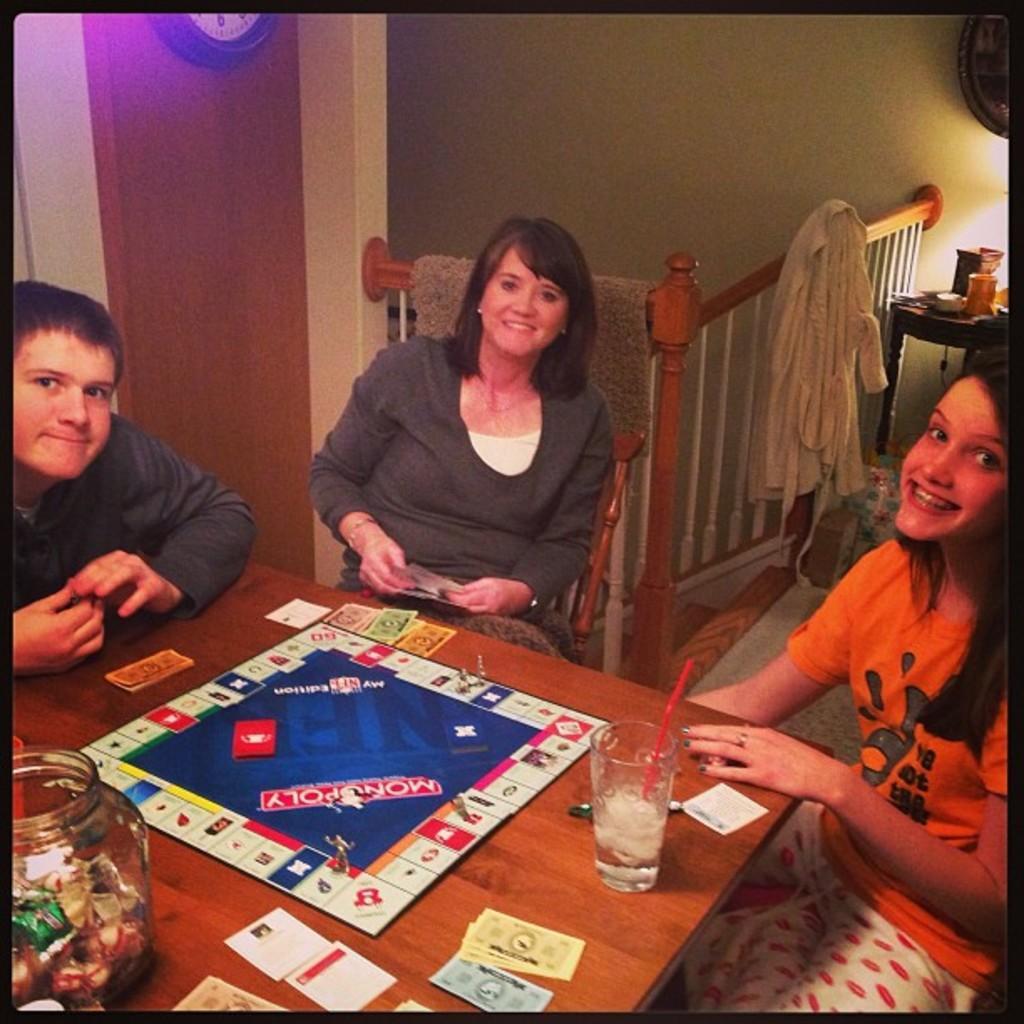Describe this image in one or two sentences. In this picture there are group of people they are sitting on the chairs around the table, they are playing the game called monopoly, there is a bed at the right side of the image and there is a door at the left side of the image, there is a glass bowl at the left side of the image on the table. 